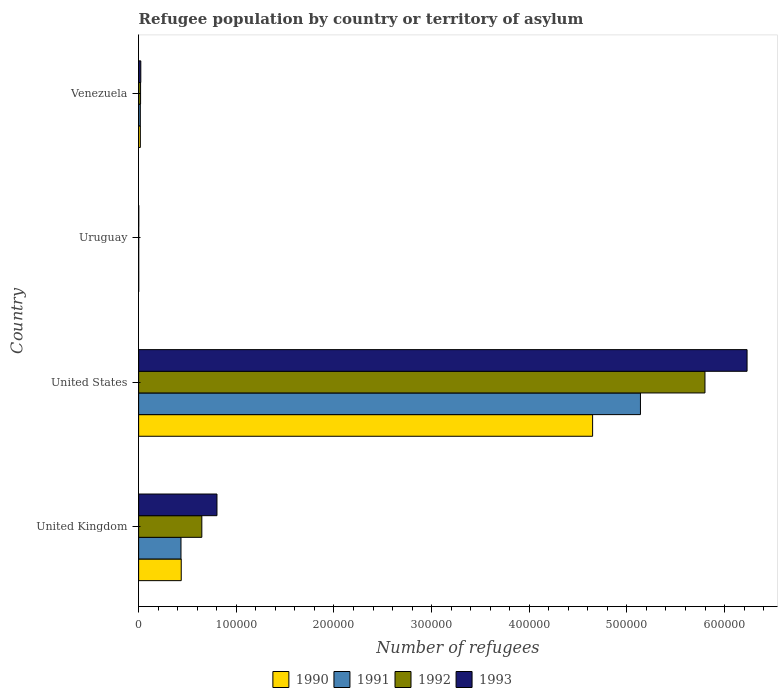How many different coloured bars are there?
Give a very brief answer. 4. How many groups of bars are there?
Offer a terse response. 4. Are the number of bars on each tick of the Y-axis equal?
Offer a terse response. Yes. In how many cases, is the number of bars for a given country not equal to the number of legend labels?
Ensure brevity in your answer.  0. What is the number of refugees in 1993 in United States?
Keep it short and to the point. 6.23e+05. Across all countries, what is the maximum number of refugees in 1993?
Offer a very short reply. 6.23e+05. In which country was the number of refugees in 1990 maximum?
Offer a terse response. United States. In which country was the number of refugees in 1993 minimum?
Make the answer very short. Uruguay. What is the total number of refugees in 1990 in the graph?
Your response must be concise. 5.10e+05. What is the difference between the number of refugees in 1990 in United Kingdom and that in Venezuela?
Offer a terse response. 4.19e+04. What is the difference between the number of refugees in 1991 in United States and the number of refugees in 1990 in United Kingdom?
Give a very brief answer. 4.70e+05. What is the average number of refugees in 1990 per country?
Your response must be concise. 1.28e+05. What is the difference between the number of refugees in 1991 and number of refugees in 1993 in United Kingdom?
Ensure brevity in your answer.  -3.69e+04. In how many countries, is the number of refugees in 1990 greater than 600000 ?
Your response must be concise. 0. What is the ratio of the number of refugees in 1993 in United States to that in Venezuela?
Your response must be concise. 280.54. What is the difference between the highest and the second highest number of refugees in 1990?
Offer a terse response. 4.21e+05. What is the difference between the highest and the lowest number of refugees in 1990?
Keep it short and to the point. 4.65e+05. Is the sum of the number of refugees in 1990 in United Kingdom and United States greater than the maximum number of refugees in 1991 across all countries?
Your answer should be compact. No. What does the 3rd bar from the bottom in United Kingdom represents?
Offer a very short reply. 1992. Is it the case that in every country, the sum of the number of refugees in 1993 and number of refugees in 1992 is greater than the number of refugees in 1991?
Ensure brevity in your answer.  Yes. How many bars are there?
Your answer should be very brief. 16. How many countries are there in the graph?
Give a very brief answer. 4. How many legend labels are there?
Offer a terse response. 4. How are the legend labels stacked?
Provide a short and direct response. Horizontal. What is the title of the graph?
Give a very brief answer. Refugee population by country or territory of asylum. What is the label or title of the X-axis?
Offer a very short reply. Number of refugees. What is the Number of refugees in 1990 in United Kingdom?
Your answer should be very brief. 4.36e+04. What is the Number of refugees of 1991 in United Kingdom?
Give a very brief answer. 4.34e+04. What is the Number of refugees of 1992 in United Kingdom?
Your response must be concise. 6.47e+04. What is the Number of refugees in 1993 in United Kingdom?
Your response must be concise. 8.02e+04. What is the Number of refugees of 1990 in United States?
Ensure brevity in your answer.  4.65e+05. What is the Number of refugees in 1991 in United States?
Your answer should be compact. 5.14e+05. What is the Number of refugees in 1992 in United States?
Provide a succinct answer. 5.80e+05. What is the Number of refugees in 1993 in United States?
Provide a succinct answer. 6.23e+05. What is the Number of refugees in 1990 in Uruguay?
Offer a very short reply. 87. What is the Number of refugees of 1992 in Uruguay?
Your answer should be compact. 90. What is the Number of refugees of 1993 in Uruguay?
Provide a short and direct response. 138. What is the Number of refugees of 1990 in Venezuela?
Keep it short and to the point. 1750. What is the Number of refugees in 1991 in Venezuela?
Offer a terse response. 1720. What is the Number of refugees of 1992 in Venezuela?
Your response must be concise. 1990. What is the Number of refugees of 1993 in Venezuela?
Your answer should be very brief. 2221. Across all countries, what is the maximum Number of refugees in 1990?
Offer a terse response. 4.65e+05. Across all countries, what is the maximum Number of refugees in 1991?
Ensure brevity in your answer.  5.14e+05. Across all countries, what is the maximum Number of refugees in 1992?
Keep it short and to the point. 5.80e+05. Across all countries, what is the maximum Number of refugees in 1993?
Give a very brief answer. 6.23e+05. Across all countries, what is the minimum Number of refugees of 1992?
Offer a terse response. 90. Across all countries, what is the minimum Number of refugees of 1993?
Provide a short and direct response. 138. What is the total Number of refugees in 1990 in the graph?
Your answer should be very brief. 5.10e+05. What is the total Number of refugees of 1991 in the graph?
Offer a terse response. 5.59e+05. What is the total Number of refugees in 1992 in the graph?
Keep it short and to the point. 6.47e+05. What is the total Number of refugees in 1993 in the graph?
Your answer should be very brief. 7.06e+05. What is the difference between the Number of refugees in 1990 in United Kingdom and that in United States?
Your answer should be very brief. -4.21e+05. What is the difference between the Number of refugees in 1991 in United Kingdom and that in United States?
Provide a succinct answer. -4.71e+05. What is the difference between the Number of refugees of 1992 in United Kingdom and that in United States?
Your response must be concise. -5.15e+05. What is the difference between the Number of refugees of 1993 in United Kingdom and that in United States?
Provide a short and direct response. -5.43e+05. What is the difference between the Number of refugees in 1990 in United Kingdom and that in Uruguay?
Keep it short and to the point. 4.35e+04. What is the difference between the Number of refugees of 1991 in United Kingdom and that in Uruguay?
Your answer should be very brief. 4.33e+04. What is the difference between the Number of refugees in 1992 in United Kingdom and that in Uruguay?
Your answer should be compact. 6.46e+04. What is the difference between the Number of refugees in 1993 in United Kingdom and that in Uruguay?
Your answer should be very brief. 8.01e+04. What is the difference between the Number of refugees in 1990 in United Kingdom and that in Venezuela?
Provide a short and direct response. 4.19e+04. What is the difference between the Number of refugees in 1991 in United Kingdom and that in Venezuela?
Your response must be concise. 4.17e+04. What is the difference between the Number of refugees of 1992 in United Kingdom and that in Venezuela?
Ensure brevity in your answer.  6.27e+04. What is the difference between the Number of refugees in 1993 in United Kingdom and that in Venezuela?
Keep it short and to the point. 7.80e+04. What is the difference between the Number of refugees of 1990 in United States and that in Uruguay?
Your answer should be compact. 4.65e+05. What is the difference between the Number of refugees in 1991 in United States and that in Uruguay?
Give a very brief answer. 5.14e+05. What is the difference between the Number of refugees in 1992 in United States and that in Uruguay?
Keep it short and to the point. 5.80e+05. What is the difference between the Number of refugees in 1993 in United States and that in Uruguay?
Offer a terse response. 6.23e+05. What is the difference between the Number of refugees in 1990 in United States and that in Venezuela?
Give a very brief answer. 4.63e+05. What is the difference between the Number of refugees in 1991 in United States and that in Venezuela?
Your response must be concise. 5.12e+05. What is the difference between the Number of refugees in 1992 in United States and that in Venezuela?
Provide a succinct answer. 5.78e+05. What is the difference between the Number of refugees in 1993 in United States and that in Venezuela?
Your answer should be very brief. 6.21e+05. What is the difference between the Number of refugees of 1990 in Uruguay and that in Venezuela?
Provide a succinct answer. -1663. What is the difference between the Number of refugees in 1991 in Uruguay and that in Venezuela?
Provide a succinct answer. -1639. What is the difference between the Number of refugees in 1992 in Uruguay and that in Venezuela?
Offer a terse response. -1900. What is the difference between the Number of refugees in 1993 in Uruguay and that in Venezuela?
Provide a succinct answer. -2083. What is the difference between the Number of refugees of 1990 in United Kingdom and the Number of refugees of 1991 in United States?
Your answer should be very brief. -4.70e+05. What is the difference between the Number of refugees in 1990 in United Kingdom and the Number of refugees in 1992 in United States?
Your response must be concise. -5.36e+05. What is the difference between the Number of refugees of 1990 in United Kingdom and the Number of refugees of 1993 in United States?
Your response must be concise. -5.79e+05. What is the difference between the Number of refugees of 1991 in United Kingdom and the Number of refugees of 1992 in United States?
Your response must be concise. -5.37e+05. What is the difference between the Number of refugees of 1991 in United Kingdom and the Number of refugees of 1993 in United States?
Offer a terse response. -5.80e+05. What is the difference between the Number of refugees of 1992 in United Kingdom and the Number of refugees of 1993 in United States?
Provide a short and direct response. -5.58e+05. What is the difference between the Number of refugees of 1990 in United Kingdom and the Number of refugees of 1991 in Uruguay?
Provide a succinct answer. 4.36e+04. What is the difference between the Number of refugees of 1990 in United Kingdom and the Number of refugees of 1992 in Uruguay?
Offer a very short reply. 4.35e+04. What is the difference between the Number of refugees in 1990 in United Kingdom and the Number of refugees in 1993 in Uruguay?
Keep it short and to the point. 4.35e+04. What is the difference between the Number of refugees in 1991 in United Kingdom and the Number of refugees in 1992 in Uruguay?
Your response must be concise. 4.33e+04. What is the difference between the Number of refugees of 1991 in United Kingdom and the Number of refugees of 1993 in Uruguay?
Give a very brief answer. 4.32e+04. What is the difference between the Number of refugees of 1992 in United Kingdom and the Number of refugees of 1993 in Uruguay?
Your answer should be compact. 6.46e+04. What is the difference between the Number of refugees in 1990 in United Kingdom and the Number of refugees in 1991 in Venezuela?
Give a very brief answer. 4.19e+04. What is the difference between the Number of refugees of 1990 in United Kingdom and the Number of refugees of 1992 in Venezuela?
Provide a short and direct response. 4.16e+04. What is the difference between the Number of refugees in 1990 in United Kingdom and the Number of refugees in 1993 in Venezuela?
Give a very brief answer. 4.14e+04. What is the difference between the Number of refugees in 1991 in United Kingdom and the Number of refugees in 1992 in Venezuela?
Your answer should be very brief. 4.14e+04. What is the difference between the Number of refugees in 1991 in United Kingdom and the Number of refugees in 1993 in Venezuela?
Provide a short and direct response. 4.12e+04. What is the difference between the Number of refugees of 1992 in United Kingdom and the Number of refugees of 1993 in Venezuela?
Make the answer very short. 6.25e+04. What is the difference between the Number of refugees in 1990 in United States and the Number of refugees in 1991 in Uruguay?
Provide a succinct answer. 4.65e+05. What is the difference between the Number of refugees in 1990 in United States and the Number of refugees in 1992 in Uruguay?
Your response must be concise. 4.65e+05. What is the difference between the Number of refugees of 1990 in United States and the Number of refugees of 1993 in Uruguay?
Provide a short and direct response. 4.65e+05. What is the difference between the Number of refugees of 1991 in United States and the Number of refugees of 1992 in Uruguay?
Provide a succinct answer. 5.14e+05. What is the difference between the Number of refugees of 1991 in United States and the Number of refugees of 1993 in Uruguay?
Offer a terse response. 5.14e+05. What is the difference between the Number of refugees in 1992 in United States and the Number of refugees in 1993 in Uruguay?
Provide a succinct answer. 5.80e+05. What is the difference between the Number of refugees in 1990 in United States and the Number of refugees in 1991 in Venezuela?
Offer a very short reply. 4.63e+05. What is the difference between the Number of refugees of 1990 in United States and the Number of refugees of 1992 in Venezuela?
Provide a short and direct response. 4.63e+05. What is the difference between the Number of refugees in 1990 in United States and the Number of refugees in 1993 in Venezuela?
Ensure brevity in your answer.  4.63e+05. What is the difference between the Number of refugees of 1991 in United States and the Number of refugees of 1992 in Venezuela?
Make the answer very short. 5.12e+05. What is the difference between the Number of refugees in 1991 in United States and the Number of refugees in 1993 in Venezuela?
Make the answer very short. 5.12e+05. What is the difference between the Number of refugees of 1992 in United States and the Number of refugees of 1993 in Venezuela?
Make the answer very short. 5.78e+05. What is the difference between the Number of refugees of 1990 in Uruguay and the Number of refugees of 1991 in Venezuela?
Your answer should be compact. -1633. What is the difference between the Number of refugees of 1990 in Uruguay and the Number of refugees of 1992 in Venezuela?
Your response must be concise. -1903. What is the difference between the Number of refugees of 1990 in Uruguay and the Number of refugees of 1993 in Venezuela?
Provide a succinct answer. -2134. What is the difference between the Number of refugees in 1991 in Uruguay and the Number of refugees in 1992 in Venezuela?
Provide a succinct answer. -1909. What is the difference between the Number of refugees of 1991 in Uruguay and the Number of refugees of 1993 in Venezuela?
Your answer should be compact. -2140. What is the difference between the Number of refugees in 1992 in Uruguay and the Number of refugees in 1993 in Venezuela?
Offer a terse response. -2131. What is the average Number of refugees of 1990 per country?
Your answer should be very brief. 1.28e+05. What is the average Number of refugees in 1991 per country?
Offer a terse response. 1.40e+05. What is the average Number of refugees of 1992 per country?
Give a very brief answer. 1.62e+05. What is the average Number of refugees in 1993 per country?
Your answer should be very brief. 1.76e+05. What is the difference between the Number of refugees in 1990 and Number of refugees in 1991 in United Kingdom?
Keep it short and to the point. 261. What is the difference between the Number of refugees of 1990 and Number of refugees of 1992 in United Kingdom?
Provide a short and direct response. -2.11e+04. What is the difference between the Number of refugees of 1990 and Number of refugees of 1993 in United Kingdom?
Make the answer very short. -3.66e+04. What is the difference between the Number of refugees in 1991 and Number of refugees in 1992 in United Kingdom?
Offer a very short reply. -2.14e+04. What is the difference between the Number of refugees of 1991 and Number of refugees of 1993 in United Kingdom?
Your answer should be very brief. -3.69e+04. What is the difference between the Number of refugees of 1992 and Number of refugees of 1993 in United Kingdom?
Your answer should be very brief. -1.55e+04. What is the difference between the Number of refugees in 1990 and Number of refugees in 1991 in United States?
Provide a succinct answer. -4.90e+04. What is the difference between the Number of refugees of 1990 and Number of refugees of 1992 in United States?
Give a very brief answer. -1.15e+05. What is the difference between the Number of refugees in 1990 and Number of refugees in 1993 in United States?
Your answer should be very brief. -1.58e+05. What is the difference between the Number of refugees in 1991 and Number of refugees in 1992 in United States?
Your response must be concise. -6.61e+04. What is the difference between the Number of refugees of 1991 and Number of refugees of 1993 in United States?
Your answer should be very brief. -1.09e+05. What is the difference between the Number of refugees of 1992 and Number of refugees of 1993 in United States?
Give a very brief answer. -4.31e+04. What is the difference between the Number of refugees of 1990 and Number of refugees of 1991 in Uruguay?
Keep it short and to the point. 6. What is the difference between the Number of refugees in 1990 and Number of refugees in 1992 in Uruguay?
Give a very brief answer. -3. What is the difference between the Number of refugees of 1990 and Number of refugees of 1993 in Uruguay?
Offer a terse response. -51. What is the difference between the Number of refugees of 1991 and Number of refugees of 1993 in Uruguay?
Make the answer very short. -57. What is the difference between the Number of refugees of 1992 and Number of refugees of 1993 in Uruguay?
Give a very brief answer. -48. What is the difference between the Number of refugees in 1990 and Number of refugees in 1991 in Venezuela?
Give a very brief answer. 30. What is the difference between the Number of refugees of 1990 and Number of refugees of 1992 in Venezuela?
Offer a terse response. -240. What is the difference between the Number of refugees in 1990 and Number of refugees in 1993 in Venezuela?
Provide a short and direct response. -471. What is the difference between the Number of refugees in 1991 and Number of refugees in 1992 in Venezuela?
Make the answer very short. -270. What is the difference between the Number of refugees in 1991 and Number of refugees in 1993 in Venezuela?
Make the answer very short. -501. What is the difference between the Number of refugees in 1992 and Number of refugees in 1993 in Venezuela?
Keep it short and to the point. -231. What is the ratio of the Number of refugees of 1990 in United Kingdom to that in United States?
Make the answer very short. 0.09. What is the ratio of the Number of refugees in 1991 in United Kingdom to that in United States?
Provide a succinct answer. 0.08. What is the ratio of the Number of refugees in 1992 in United Kingdom to that in United States?
Ensure brevity in your answer.  0.11. What is the ratio of the Number of refugees of 1993 in United Kingdom to that in United States?
Give a very brief answer. 0.13. What is the ratio of the Number of refugees in 1990 in United Kingdom to that in Uruguay?
Offer a very short reply. 501.52. What is the ratio of the Number of refugees of 1991 in United Kingdom to that in Uruguay?
Your answer should be compact. 535.44. What is the ratio of the Number of refugees in 1992 in United Kingdom to that in Uruguay?
Offer a terse response. 719.18. What is the ratio of the Number of refugees of 1993 in United Kingdom to that in Uruguay?
Provide a succinct answer. 581.38. What is the ratio of the Number of refugees in 1990 in United Kingdom to that in Venezuela?
Provide a succinct answer. 24.93. What is the ratio of the Number of refugees of 1991 in United Kingdom to that in Venezuela?
Provide a short and direct response. 25.22. What is the ratio of the Number of refugees in 1992 in United Kingdom to that in Venezuela?
Keep it short and to the point. 32.53. What is the ratio of the Number of refugees in 1993 in United Kingdom to that in Venezuela?
Provide a short and direct response. 36.12. What is the ratio of the Number of refugees in 1990 in United States to that in Uruguay?
Ensure brevity in your answer.  5343.53. What is the ratio of the Number of refugees of 1991 in United States to that in Uruguay?
Your response must be concise. 6344.22. What is the ratio of the Number of refugees in 1992 in United States to that in Uruguay?
Your answer should be very brief. 6443.91. What is the ratio of the Number of refugees in 1993 in United States to that in Uruguay?
Your answer should be very brief. 4514.99. What is the ratio of the Number of refugees in 1990 in United States to that in Venezuela?
Your answer should be compact. 265.65. What is the ratio of the Number of refugees in 1991 in United States to that in Venezuela?
Ensure brevity in your answer.  298.77. What is the ratio of the Number of refugees in 1992 in United States to that in Venezuela?
Your answer should be compact. 291.43. What is the ratio of the Number of refugees in 1993 in United States to that in Venezuela?
Make the answer very short. 280.54. What is the ratio of the Number of refugees of 1990 in Uruguay to that in Venezuela?
Your response must be concise. 0.05. What is the ratio of the Number of refugees in 1991 in Uruguay to that in Venezuela?
Your response must be concise. 0.05. What is the ratio of the Number of refugees of 1992 in Uruguay to that in Venezuela?
Provide a succinct answer. 0.05. What is the ratio of the Number of refugees of 1993 in Uruguay to that in Venezuela?
Offer a very short reply. 0.06. What is the difference between the highest and the second highest Number of refugees in 1990?
Make the answer very short. 4.21e+05. What is the difference between the highest and the second highest Number of refugees in 1991?
Offer a very short reply. 4.71e+05. What is the difference between the highest and the second highest Number of refugees of 1992?
Provide a short and direct response. 5.15e+05. What is the difference between the highest and the second highest Number of refugees of 1993?
Your response must be concise. 5.43e+05. What is the difference between the highest and the lowest Number of refugees in 1990?
Your answer should be compact. 4.65e+05. What is the difference between the highest and the lowest Number of refugees of 1991?
Your answer should be very brief. 5.14e+05. What is the difference between the highest and the lowest Number of refugees of 1992?
Your answer should be compact. 5.80e+05. What is the difference between the highest and the lowest Number of refugees of 1993?
Your answer should be very brief. 6.23e+05. 